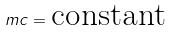Convert formula to latex. <formula><loc_0><loc_0><loc_500><loc_500>m c = \text {constant}</formula> 